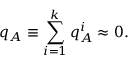<formula> <loc_0><loc_0><loc_500><loc_500>q _ { A } \equiv \sum _ { i = 1 } ^ { k } { q _ { A } ^ { i } \approx 0 } .</formula> 